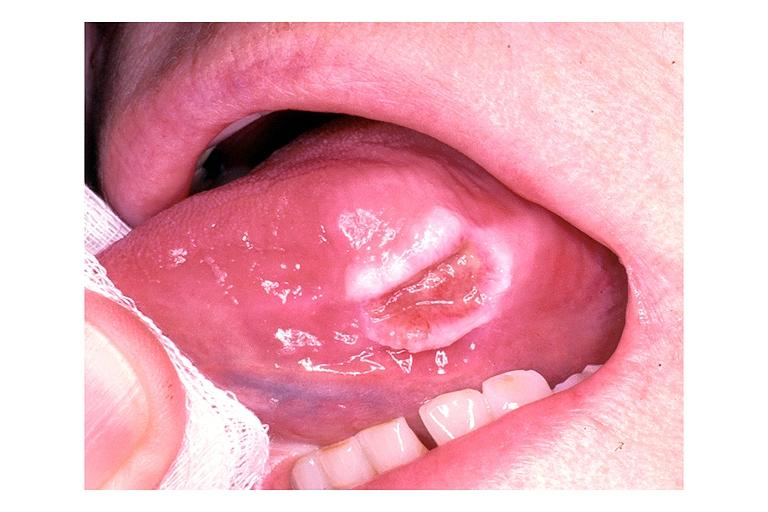does this image show traumatic ulcer?
Answer the question using a single word or phrase. Yes 